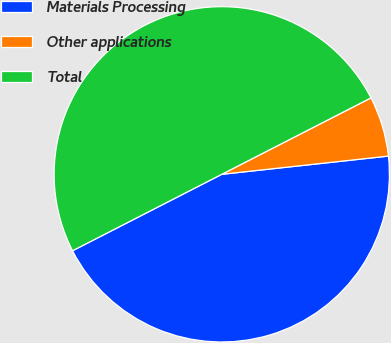<chart> <loc_0><loc_0><loc_500><loc_500><pie_chart><fcel>Materials Processing<fcel>Other applications<fcel>Total<nl><fcel>44.2%<fcel>5.8%<fcel>50.0%<nl></chart> 